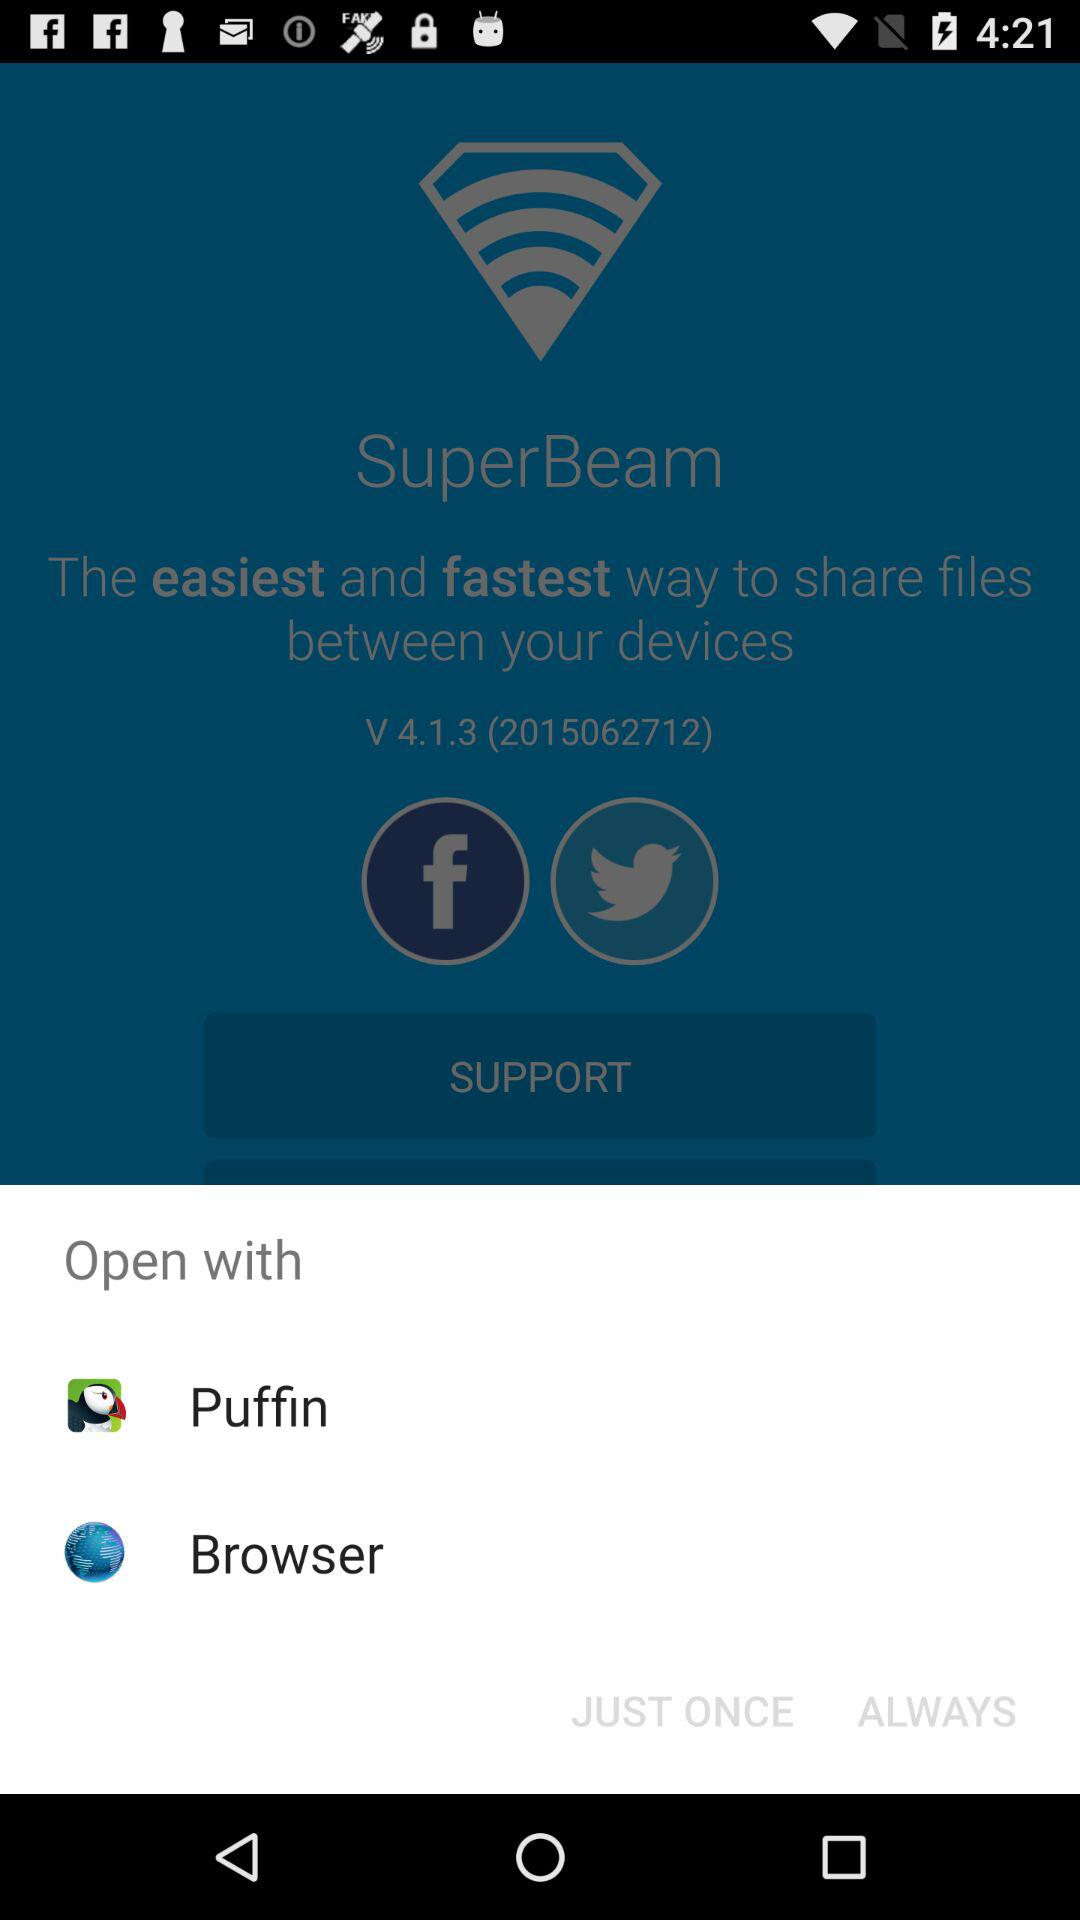What are the options to open? The options to open are "Puffin" and "Browser". 